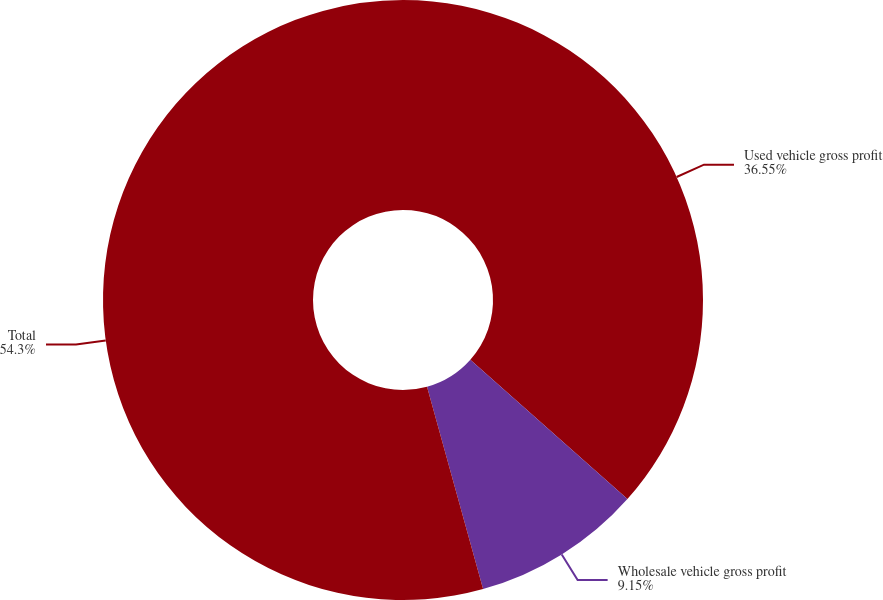Convert chart. <chart><loc_0><loc_0><loc_500><loc_500><pie_chart><fcel>Used vehicle gross profit<fcel>Wholesale vehicle gross profit<fcel>Total<nl><fcel>36.55%<fcel>9.15%<fcel>54.3%<nl></chart> 